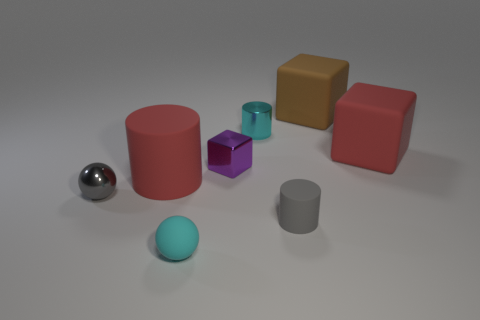Add 1 large objects. How many objects exist? 9 Subtract all small gray cylinders. How many cylinders are left? 2 Subtract all cyan cylinders. How many cylinders are left? 2 Subtract all cubes. How many objects are left? 5 Subtract 1 blocks. How many blocks are left? 2 Subtract all gray cubes. Subtract all green balls. How many cubes are left? 3 Subtract all red things. Subtract all big red cylinders. How many objects are left? 5 Add 4 red cylinders. How many red cylinders are left? 5 Add 1 small brown rubber balls. How many small brown rubber balls exist? 1 Subtract 0 blue cylinders. How many objects are left? 8 